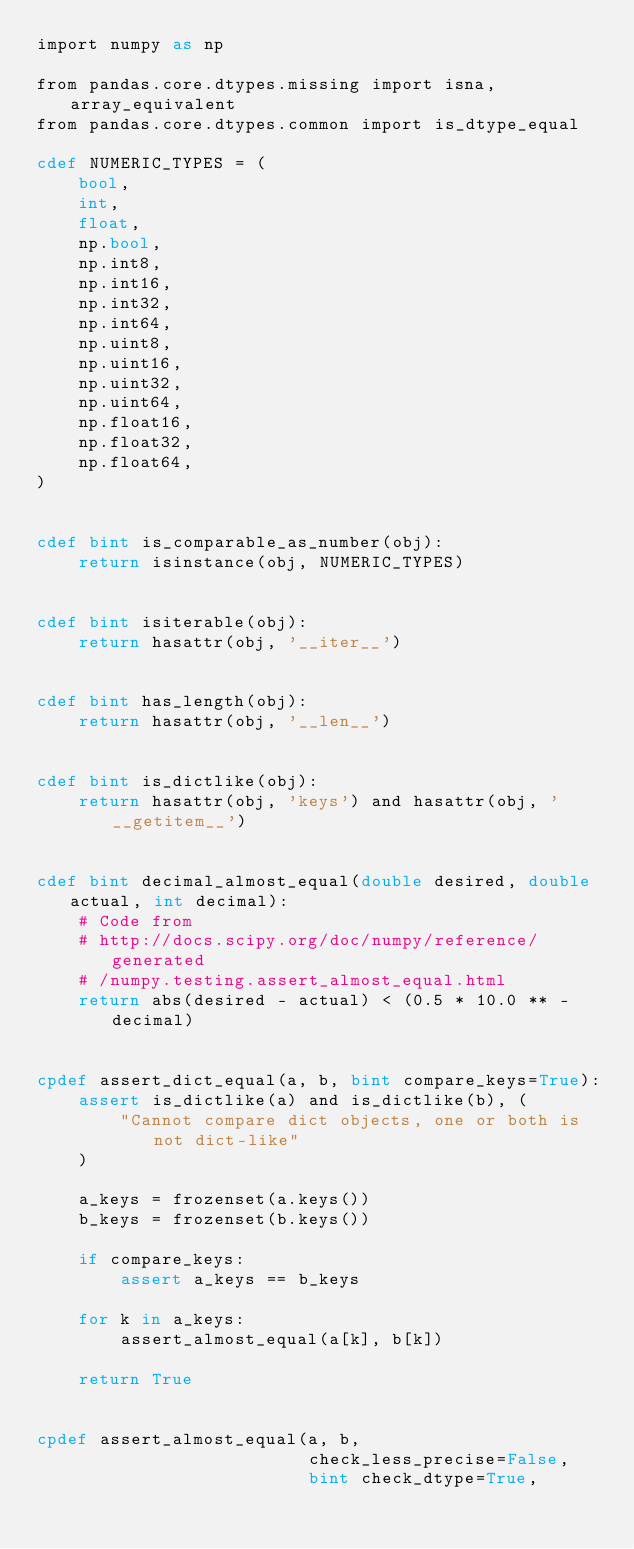Convert code to text. <code><loc_0><loc_0><loc_500><loc_500><_Cython_>import numpy as np

from pandas.core.dtypes.missing import isna, array_equivalent
from pandas.core.dtypes.common import is_dtype_equal

cdef NUMERIC_TYPES = (
    bool,
    int,
    float,
    np.bool,
    np.int8,
    np.int16,
    np.int32,
    np.int64,
    np.uint8,
    np.uint16,
    np.uint32,
    np.uint64,
    np.float16,
    np.float32,
    np.float64,
)


cdef bint is_comparable_as_number(obj):
    return isinstance(obj, NUMERIC_TYPES)


cdef bint isiterable(obj):
    return hasattr(obj, '__iter__')


cdef bint has_length(obj):
    return hasattr(obj, '__len__')


cdef bint is_dictlike(obj):
    return hasattr(obj, 'keys') and hasattr(obj, '__getitem__')


cdef bint decimal_almost_equal(double desired, double actual, int decimal):
    # Code from
    # http://docs.scipy.org/doc/numpy/reference/generated
    # /numpy.testing.assert_almost_equal.html
    return abs(desired - actual) < (0.5 * 10.0 ** -decimal)


cpdef assert_dict_equal(a, b, bint compare_keys=True):
    assert is_dictlike(a) and is_dictlike(b), (
        "Cannot compare dict objects, one or both is not dict-like"
    )

    a_keys = frozenset(a.keys())
    b_keys = frozenset(b.keys())

    if compare_keys:
        assert a_keys == b_keys

    for k in a_keys:
        assert_almost_equal(a[k], b[k])

    return True


cpdef assert_almost_equal(a, b,
                          check_less_precise=False,
                          bint check_dtype=True,</code> 